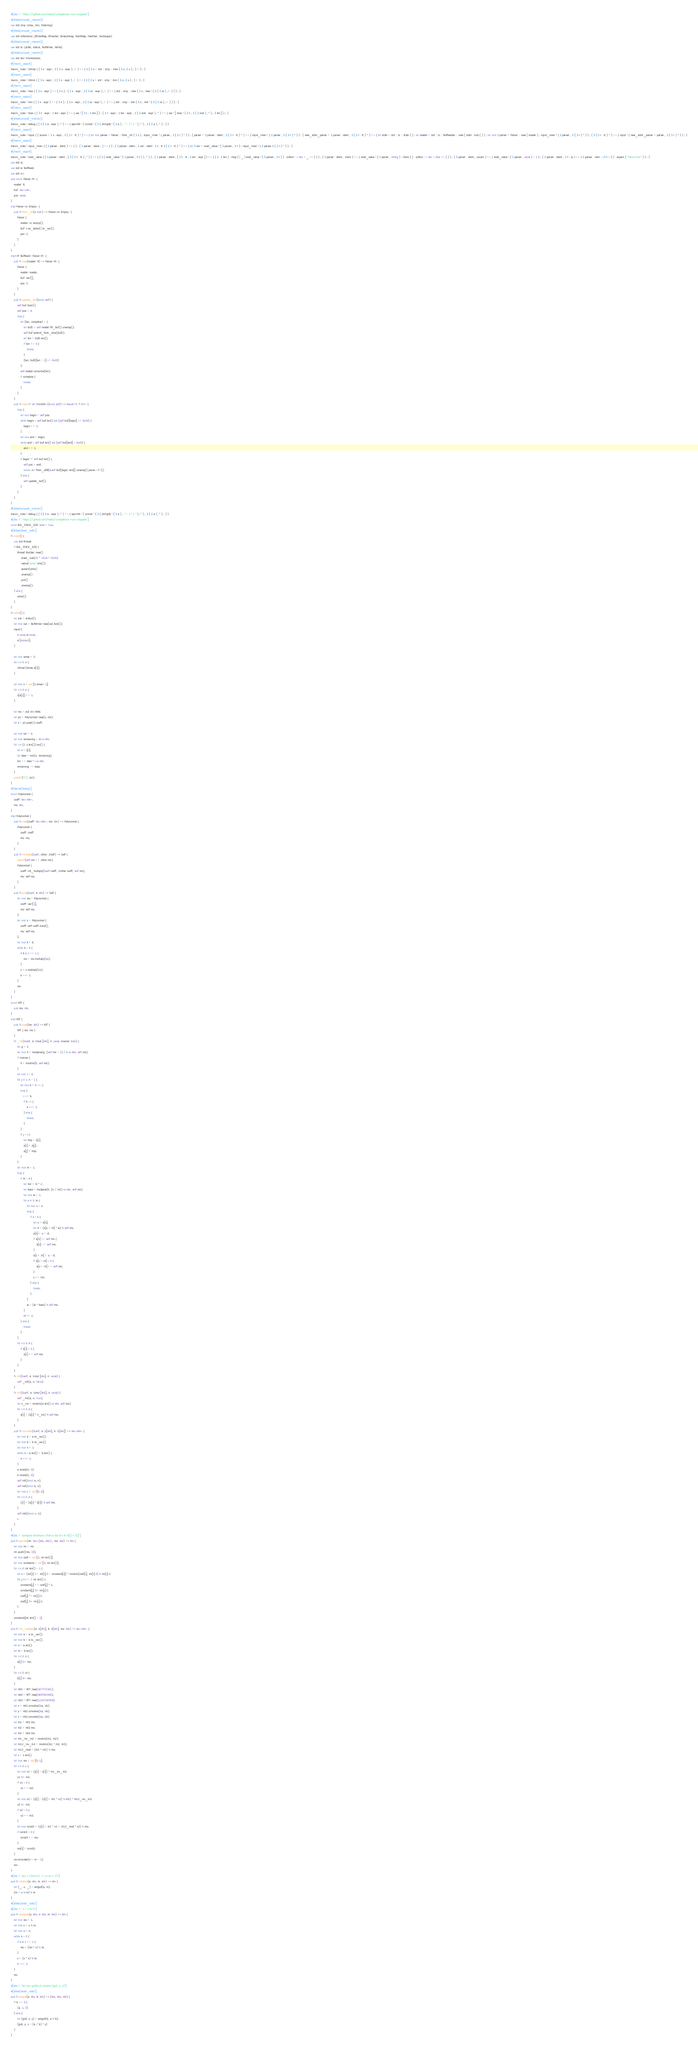<code> <loc_0><loc_0><loc_500><loc_500><_Rust_>#[doc = " https://github.com/hatoo/competitive-rust-snippets"]
#[allow(unused_imports)]
use std::cmp::{max, min, Ordering};
#[allow(unused_imports)]
use std::collections::{BTreeMap, BTreeSet, BinaryHeap, HashMap, HashSet, VecDeque};
#[allow(unused_imports)]
use std::io::{stdin, stdout, BufWriter, Write};
#[allow(unused_imports)]
use std::iter::FromIterator;
#[macro_export]
macro_rules ! chmax { ( $ x : expr , $ ( $ v : expr ) ,+ ) => { $ ( $ x = std :: cmp :: max ( $ x ,$ v ) ; ) + } ; }
#[macro_export]
macro_rules ! chmin { ( $ x : expr , $ ( $ v : expr ) ,+ ) => { $ ( $ x = std :: cmp :: min ( $ x ,$ v ) ; ) + } ; }
#[macro_export]
macro_rules ! max { ( $ x : expr ) => ( $ x ) ; ( $ x : expr , $ ( $ xs : expr ) ,+ ) => { std :: cmp :: max ( $ x , max ! ( $ ( $ xs ) ,+ ) ) } ; }
#[macro_export]
macro_rules ! min { ( $ x : expr ) => ( $ x ) ; ( $ x : expr , $ ( $ xs : expr ) ,+ ) => { std :: cmp :: min ( $ x , min ! ( $ ( $ xs ) ,+ ) ) } ; }
#[macro_export]
macro_rules ! dvec { ( $ t : expr ; $ len : expr ) => { vec ! [ $ t ; $ len ] } ; ( $ t : expr ; $ len : expr , $ ( $ rest : expr ) ,* ) => { vec ! [ dvec ! ( $ t ; $ ( $ rest ) ,* ) ; $ len ] } ; }
#[allow(unused_macros)]
macro_rules ! debug { ( $ ( $ a : expr ) ,* ) => { eprintln ! ( concat ! ( $ ( stringify ! ( $ a ) , " = {:?}, " ) ,* ) , $ ( $ a ) ,* ) ; } }
#[macro_export]
macro_rules ! input { ( source = $ s : expr , $ ( $ r : tt ) * ) => { let mut parser = Parser :: from_str ( $ s ) ; input_inner ! { parser , $ ( $ r ) * } } ; ( parser = $ parser : ident , $ ( $ r : tt ) * ) => { input_inner ! { $ parser , $ ( $ r ) * } } ; ( new_stdin_parser = $ parser : ident , $ ( $ r : tt ) * ) => { let stdin = std :: io :: stdin ( ) ; let reader = std :: io :: BufReader :: new ( stdin . lock ( ) ) ; let mut $ parser = Parser :: new ( reader ) ; input_inner ! { $ parser , $ ( $ r ) * } } ; ( $ ( $ r : tt ) * ) => { input ! { new_stdin_parser = parser , $ ( $ r ) * } } ; }
#[macro_export]
macro_rules ! input_inner { ( $ parser : ident ) => { } ; ( $ parser : ident , ) => { } ; ( $ parser : ident , $ var : ident : $ t : tt $ ( $ r : tt ) * ) => { let $ var = read_value ! ( $ parser , $ t ) ; input_inner ! { $ parser $ ( $ r ) * } } ; }
#[macro_export]
macro_rules ! read_value { ( $ parser : ident , ( $ ( $ t : tt ) ,* ) ) => { ( $ ( read_value ! ( $ parser , $ t ) ) ,* ) } ; ( $ parser : ident , [ $ t : tt ; $ len : expr ] ) => { ( 0 ..$ len ) . map ( | _ | read_value ! ( $ parser , $ t ) ) . collect ::< Vec < _ >> ( ) } ; ( $ parser : ident , chars ) => { read_value ! ( $ parser , String ) . chars ( ) . collect ::< Vec < char >> ( ) } ; ( $ parser : ident , usize1 ) => { read_value ! ( $ parser , usize ) - 1 } ; ( $ parser : ident , $ t : ty ) => { $ parser . next ::<$ t > ( ) . expect ( "Parse error" ) } ; }
use std::io;
use std::io::BufRead;
use std::str;
pub struct Parser<R> {
    reader: R,
    buf: Vec<u8>,
    pos: usize,
}
impl Parser<io::Empty> {
    pub fn from_str(s: &str) -> Parser<io::Empty> {
        Parser {
            reader: io::empty(),
            buf: s.as_bytes().to_vec(),
            pos: 0,
        }
    }
}
impl<R: BufRead> Parser<R> {
    pub fn new(reader: R) -> Parser<R> {
        Parser {
            reader: reader,
            buf: vec![],
            pos: 0,
        }
    }
    pub fn update_buf(&mut self) {
        self.buf.clear();
        self.pos = 0;
        loop {
            let (len, complete) = {
                let buf2 = self.reader.fill_buf().unwrap();
                self.buf.extend_from_slice(buf2);
                let len = buf2.len();
                if len == 0 {
                    break;
                }
                (len, buf2[len - 1] <= 0x20)
            };
            self.reader.consume(len);
            if complete {
                break;
            }
        }
    }
    pub fn next<T: str::FromStr>(&mut self) -> Result<T, T::Err> {
        loop {
            let mut begin = self.pos;
            while begin < self.buf.len() && (self.buf[begin] <= 0x20) {
                begin += 1;
            }
            let mut end = begin;
            while end < self.buf.len() && (self.buf[end] > 0x20) {
                end += 1;
            }
            if begin != self.buf.len() {
                self.pos = end;
                return str::from_utf8(&self.buf[begin..end]).unwrap().parse::<T>();
            } else {
                self.update_buf();
            }
        }
    }
}
#[allow(unused_macros)]
macro_rules ! debug { ( $ ( $ a : expr ) ,* ) => { eprintln ! ( concat ! ( $ ( stringify ! ( $ a ) , " = {:?}, " ) ,* ) , $ ( $ a ) ,* ) ; } }
#[doc = " https://github.com/hatoo/competitive-rust-snippets"]
const BIG_STACK_SIZE: bool = true;
#[allow(dead_code)]
fn main() {
    use std::thread;
    if BIG_STACK_SIZE {
        thread::Builder::new()
            .stack_size(32 * 1024 * 1024)
            .name("solve".into())
            .spawn(solve)
            .unwrap()
            .join()
            .unwrap();
    } else {
        solve();
    }
}
fn solve() {
    let out = stdout();
    let mut out = BufWriter::new(out.lock());
    input!{
        n:usize,m:usize,
        a:[usize;n],
    }

    let mut amax = 0;
    for i in 0..n {
        chmax!(amax,a[i]);
    }

    let mut x = vec![0;amax+1];
    for i in 0..n {
        x[a[i]] += 1;
    }

    let mo = std::i64::MAX;
    let p1 = Polynomial::new(x, mo);
    let z = p1.pow(2).coeff;

    let mut tot = 0;
    let mut remaining = m as i64;
    for i in (0..z.len()).rev() {
        let v = z[i];
        let take = min(v, remaining);
        tot += take * i as i64;
        remaining -= take;
    }
    println!("{}", tot);
}
#[derive(Debug)]
struct Polynomial {
    coeff: Vec<i64>,
    mo: i64,
}
impl Polynomial {
    pub fn new(coeff: Vec<i64>, mo: i64) -> Polynomial {
        Polynomial {
            coeff: coeff,
            mo: mo,
        }
    }
    pub fn multiply(&self, other: &Self) -> Self {
        assert!(self.mo == other.mo);
        Polynomial {
            coeff: ntt_multiply(&self.coeff, &other.coeff, self.mo),
            mo: self.mo,
        }
    }
    pub fn pow(&self, k: i64) -> Self {
        let mut res = Polynomial {
            coeff: vec![1],
            mo: self.mo,
        };
        let mut x = Polynomial {
            coeff: self.coeff.clone(),
            mo: self.mo,
        };
        let mut k = k;
        while k > 0 {
            if k & 1 == 1 {
                res = res.multiply(&x);
            }
            x = x.multiply(&x);
            k >>= 1;
        }
        res
    }
}
struct NTT {
    pub mo: i64,
}
impl NTT {
    pub fn new(mo: i64) -> NTT {
        NTT { mo: mo }
    }
    fn _ntt(&self, a: &mut [i64], n: usize, inverse: bool) {
        let g = 3;
        let mut h = modpow(g, (self.mo - 1) / n as i64, self.mo);
        if inverse {
            h = modinv(h, self.mo);
        }
        let mut i = 0;
        for j in 1..n - 1 {
            let mut k = n >> 1;
            loop {
                i ^= k;
                if k > i {
                    k >>= 1;
                } else {
                    break;
                }
            }
            if j < i {
                let tmp = a[i];
                a[i] = a[j];
                a[j] = tmp;
            }
        }
        let mut m = 1;
        loop {
            if m < n {
                let m2 = m * 2;
                let base = modpow(h, (n / m2) as i64, self.mo);
                let mut w = 1;
                for x in 0..m {
                    let mut s = x;
                    loop {
                        if s < n {
                            let u = a[s];
                            let d = (a[s + m] * w) % self.mo;
                            a[s] = u + d;
                            if a[s] >= self.mo {
                                a[s] -= self.mo;
                            }
                            a[s + m] = u - d;
                            if a[s + m] < 0 {
                                a[s + m] += self.mo;
                            }
                            s += m2;
                        } else {
                            break;
                        }
                    }
                    w = (w * base) % self.mo;
                }
                m *= 2;
            } else {
                break;
            }
        }
        for i in 0..n {
            if a[i] < 0 {
                a[i] += self.mo;
            }
        }
    }
    fn ntt(&self, a: &mut [i64], n: usize) {
        self._ntt(a, n, false);
    }
    fn intt(&self, a: &mut [i64], n: usize) {
        self._ntt(a, n, true);
        let n_inv = modinv(a.len() as i64, self.mo);
        for i in 0..n {
            a[i] = (a[i] * n_inv) % self.mo;
        }
    }
    pub fn convolve(&self, a: &[i64], b: &[i64]) -> Vec<i64> {
        let mut a = a.to_vec();
        let mut b = b.to_vec();
        let mut n = 1;
        while n < a.len() + b.len() {
            n <<= 1;
        }
        a.resize(n, 0);
        b.resize(n, 0);
        self.ntt(&mut a, n);
        self.ntt(&mut b, n);
        let mut c = vec![0; n];
        for i in 0..n {
            c[i] = (a[i] * b[i]) % self.mo;
        }
        self.intt(&mut c, n);
        c
    }
}
#[doc = "compute minimum x from a list of x % m[i] = r[i]"]
pub fn garner(mr: Vec<(i64, i64)>, mo: i64) -> i64 {
    let mut mr = mr;
    mr.push((mo, 0));
    let mut coef = vec![1; mr.len()];
    let mut constants = vec![0; mr.len()];
    for i in 0..mr.len() - 1 {
        let v = (mr[i].1 + mr[i].0 - constants[i]) * modinv(coef[i], mr[i].0) % mr[i].0;
        for j in i + 1..mr.len() {
            constants[j] += coef[j] * v;
            constants[j] %= mr[j].0;
            coef[j] *= mr[i].0;
            coef[j] %= mr[j].0;
        }
    }
    constants[mr.len() - 1]
}
pub fn ntt_multiply(a: &[i64], b: &[i64], mo: i64) -> Vec<i64> {
    let mut a = a.to_vec();
    let mut b = b.to_vec();
    let n = a.len();
    let m = b.len();
    for i in 0..n {
        a[i] %= mo;
    }
    for i in 0..m {
        b[i] %= mo;
    }
    let ntt1 = NTT::new(167772161);
    let ntt2 = NTT::new(469762049);
    let ntt3 = NTT::new(1224736769);
    let x = ntt1.convolve(&a, &b);
    let y = ntt2.convolve(&a, &b);
    let z = ntt3.convolve(&a, &b);
    let m1 = ntt1.mo;
    let m2 = ntt2.mo;
    let m3 = ntt3.mo;
    let m1_inv_m2 = modinv(m1, m2);
    let m12_inv_m3 = modinv(m1 * m2, m3);
    let m12_mod = (m1 * m2) % mo;
    let L = x.len();
    let mut res = vec![0; L];
    for i in 0..L {
        let mut v1 = (y[i] - x[i]) * m1_inv_m2;
        v1 %= m2;
        if v1 < 0 {
            v1 += m2;
        }
        let mut v2 = (z[i] - (x[i] + m1 * v1) % m3) * m12_inv_m3;
        v2 %= m3;
        if v2 < 0 {
            v2 += m3;
        }
        let mut const3 = (x[i] + m1 * v1 + m12_mod * v2) % mo;
        if const3 < 0 {
            const3 += mo;
        }
        res[i] = const3;
    }
    res.truncate(n + m - 1);
    res
}
#[doc = "ay=1 (mod m) -> y=a^{-1}"]
pub fn modinv(a: i64, m: i64) -> i64 {
    let (_, x, _) = extgcd(a, m);
    (m + x % m) % m
}
#[allow(dead_code)]
#[doc = " x ^ n % m"]
pub fn modpow(x: i64, n: i64, m: i64) -> i64 {
    let mut res = 1;
    let mut x = x % m;
    let mut n = n;
    while n > 0 {
        if n & 1 == 1 {
            res = (res * x) % m;
        }
        x = (x * x) % m;
        n >>= 1;
    }
    res
}
#[doc = "ax+by=gcd(a,b) returns (gcd, x, y)"]
#[allow(dead_code)]
pub fn extgcd(a: i64, b: i64) -> (i64, i64, i64) {
    if b == 0 {
        (a, 1, 0)
    } else {
        let (gcd, x, y) = extgcd(b, a % b);
        (gcd, y, x - (a / b) * y)
    }
}</code> 